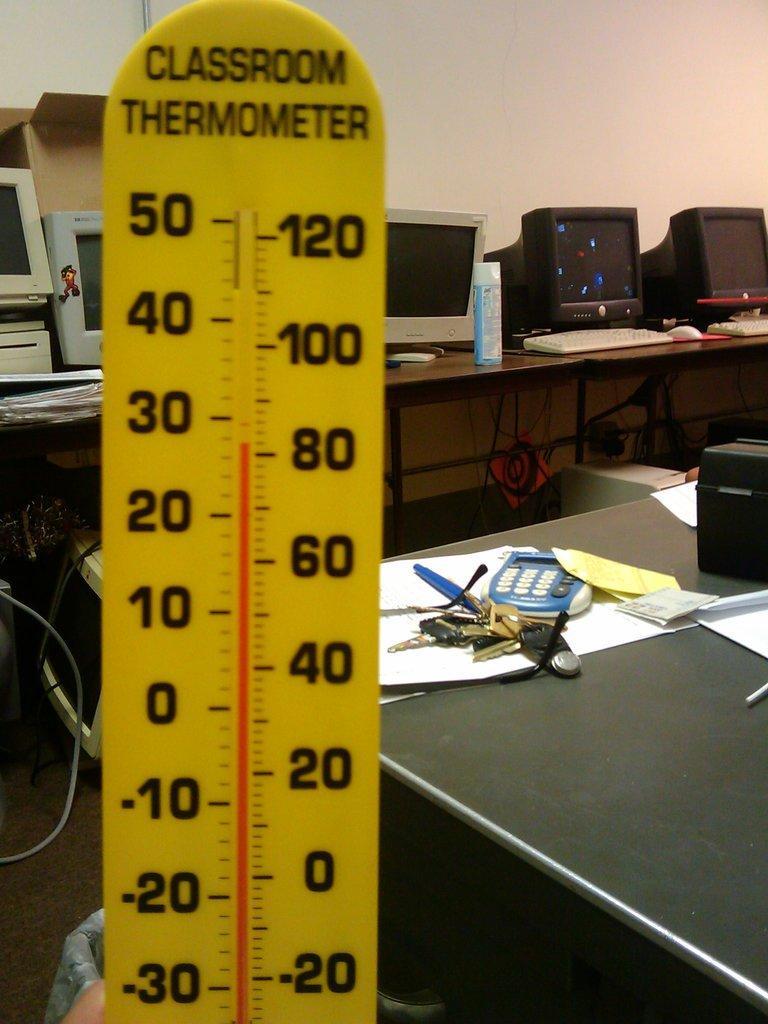Describe this image in one or two sentences. In Front of the picture we can see a thermometer. On the background we can see a wall in white colour. We can see computers on the table. Here art the right side of the picture we can see table and on the table we can see a calculator , keys, papers and a box on it. 